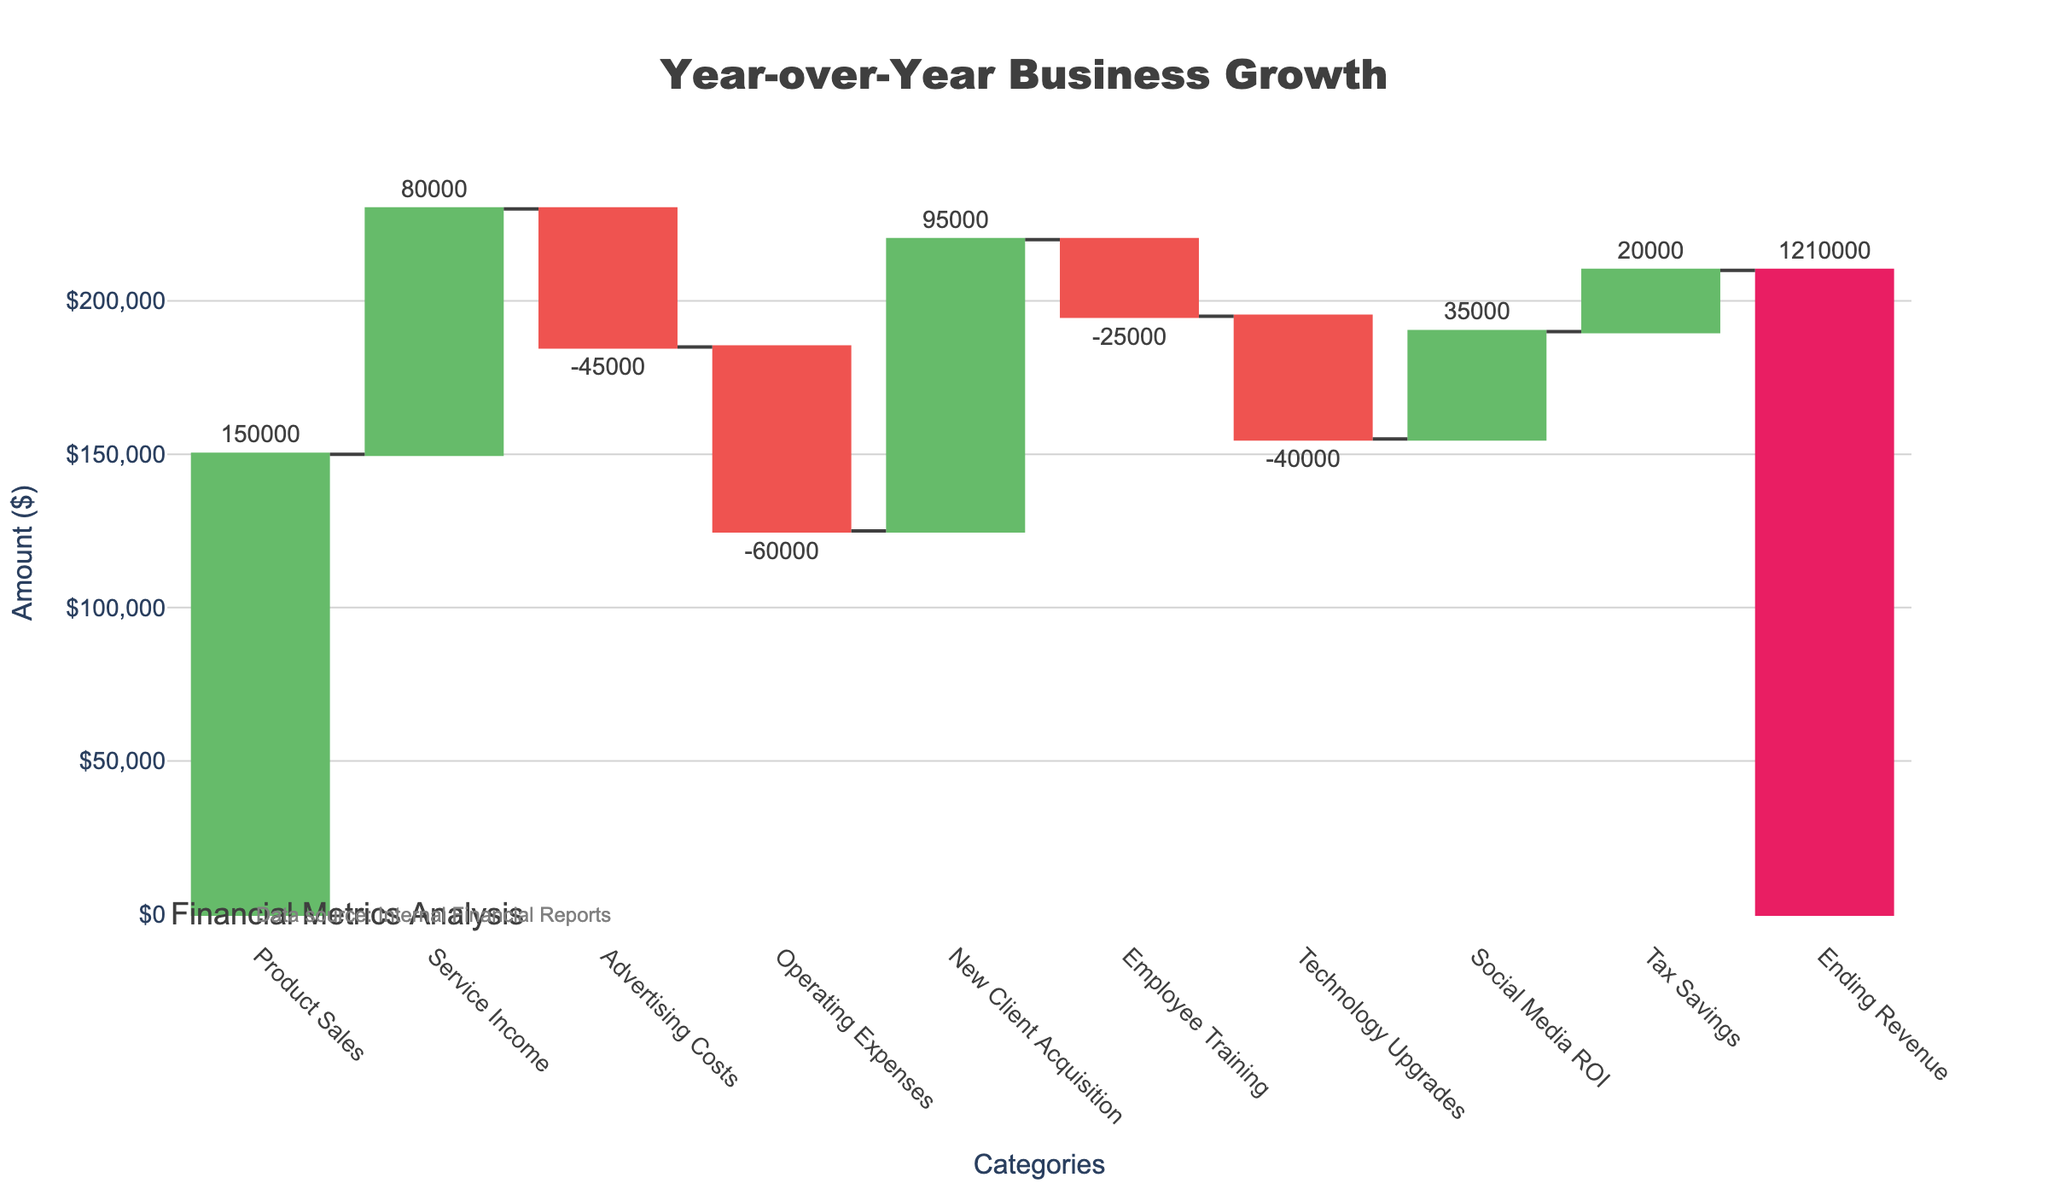What is the title of the chart? The title of the chart is positioned at the top and reads "Year-over-Year Business Growth". This is derived from the title attribute of the figure.
Answer: Year-over-Year Business Growth How much does advertising cost affect the revenue? According to the figure, "Advertising Costs" has a value of -$45,000, which decreases the revenue.
Answer: -$45,000 Which category contributes the most to the revenue? The "Product Sales" category contributes the most to the revenue, with a value of $150,000.
Answer: Product Sales What is the new revenue after accounting for Operating Expenses? Starting Revenue is $1,000,000, and Operating Expenses are -$60,000. Adding them gives $1,000,000 - $60,000 = $940,000.
Answer: $940,000 What is the net effect of New Client Acquisition and Employee Training on the revenue? New Client Acquisition adds $95,000, while Employee Training costs -$25,000. The net effect is $95,000 - $25,000 = $70,000.
Answer: $70,000 Did the Tax Savings increase or decrease the revenue and by how much? The Tax Savings increased the revenue by $20,000, as indicated by the positive value.
Answer: Increased by $20,000 What is the final revenue at the end of the year? The ending revenue is given as $1,210,000, which is displayed at the end of the waterfall chart.
Answer: $1,210,000 How does the impact of Social Media ROI compare to Technology Upgrades? Social Media ROI adds $35,000 while Technology Upgrades cost -$40,000. Social Media ROI increases revenue by a lesser amount compared to Technology Upgrades' decrease.
Answer: Social Media ROI adds less than Technology Upgrades costs What are the total additional expenses (negative values) shown in the chart? The negative values are -$45,000 (Advertising Costs), -$60,000 (Operating Expenses), -$25,000 (Employee Training), and -$40,000 (Technology Upgrades). Summing these gives -$45,000 - $60,000 - $25,000 - $40,000 = -$170,000.
Answer: -$170,000 If we exclude Tax Savings, what would be the ending revenue? The ending revenue is $1,210,000, and Tax Savings contribute $20,000. Excluding Tax Savings, the ending revenue would be $1,210,000 - $20,000 = $1,190,000.
Answer: $1,190,000 